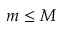Convert formula to latex. <formula><loc_0><loc_0><loc_500><loc_500>m \leq M</formula> 